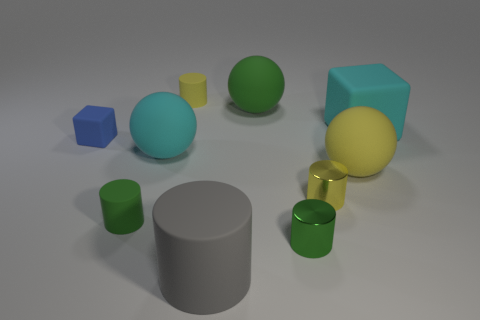Subtract all tiny shiny cylinders. How many cylinders are left? 3 Subtract 2 cylinders. How many cylinders are left? 3 Subtract 0 blue spheres. How many objects are left? 10 Subtract all cubes. How many objects are left? 8 Subtract all brown cylinders. Subtract all green spheres. How many cylinders are left? 5 Subtract all red balls. How many blue cylinders are left? 0 Subtract all small green matte cylinders. Subtract all green cylinders. How many objects are left? 7 Add 7 metal cylinders. How many metal cylinders are left? 9 Add 8 small red things. How many small red things exist? 8 Subtract all blue cubes. How many cubes are left? 1 